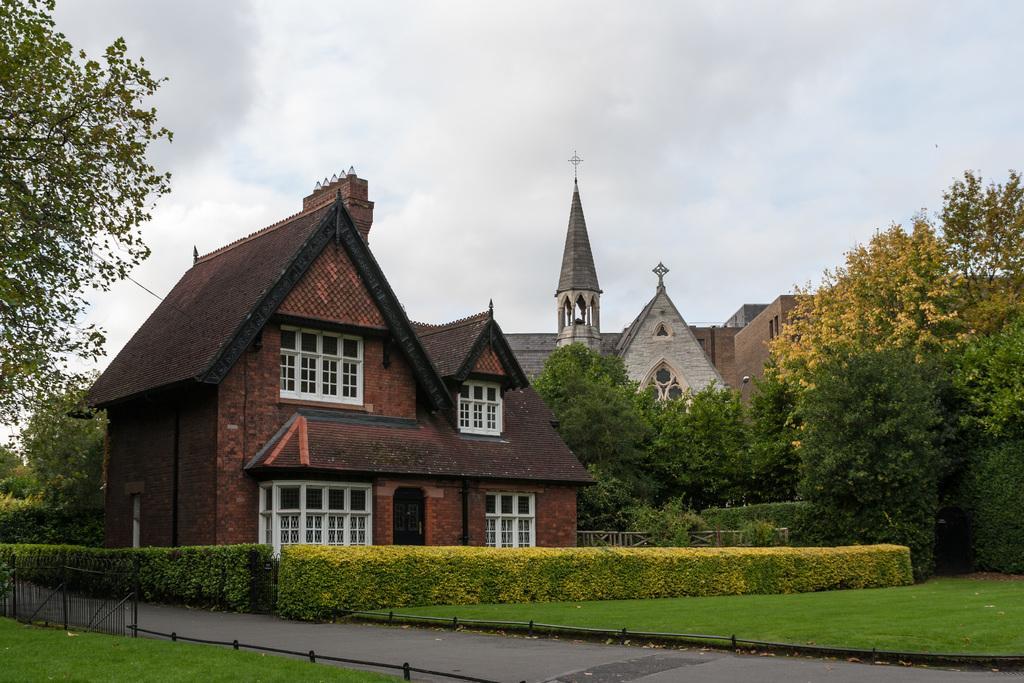How would you summarize this image in a sentence or two? In this picture I can observe buildings in the middle of the picture. There are some plants and trees in front of the buildings. In the background I can observe some clouds in the sky. 